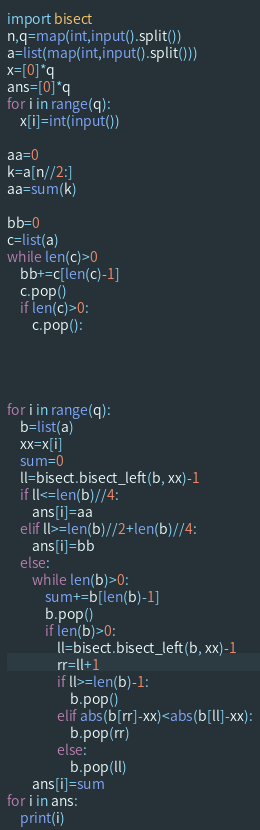<code> <loc_0><loc_0><loc_500><loc_500><_Python_>import bisect
n,q=map(int,input().split())
a=list(map(int,input().split()))
x=[0]*q
ans=[0]*q
for i in range(q):
    x[i]=int(input())

aa=0
k=a[n//2:]
aa=sum(k)
    
bb=0
c=list(a)
while len(c)>0
    bb+=c[len(c)-1]
    c.pop()
    if len(c)>0:
        c.pop():




for i in range(q):
    b=list(a)
    xx=x[i]
    sum=0
    ll=bisect.bisect_left(b, xx)-1
    if ll<=len(b)//4:
        ans[i]=aa
    elif ll>=len(b)//2+len(b)//4:
        ans[i]=bb
    else:
        while len(b)>0:
            sum+=b[len(b)-1]
            b.pop()
            if len(b)>0:
                ll=bisect.bisect_left(b, xx)-1
                rr=ll+1
                if ll>=len(b)-1:
                    b.pop()
                elif abs(b[rr]-xx)<abs(b[ll]-xx):
                    b.pop(rr)    
                else:
                    b.pop(ll)
        ans[i]=sum
for i in ans:
    print(i)</code> 